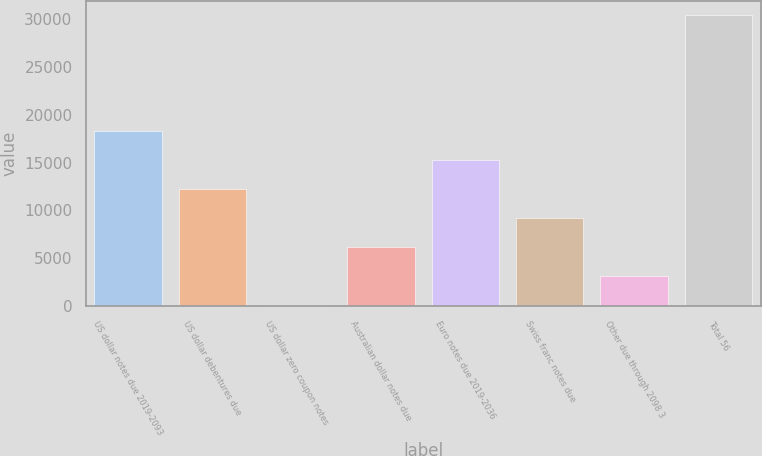Convert chart. <chart><loc_0><loc_0><loc_500><loc_500><bar_chart><fcel>US dollar notes due 2019-2093<fcel>US dollar debentures due<fcel>US dollar zero coupon notes<fcel>Australian dollar notes due<fcel>Euro notes due 2019-2036<fcel>Swiss franc notes due<fcel>Other due through 2098 3<fcel>Total 56<nl><fcel>18281.8<fcel>12242.2<fcel>163<fcel>6202.6<fcel>15262<fcel>9222.4<fcel>3182.8<fcel>30361<nl></chart> 